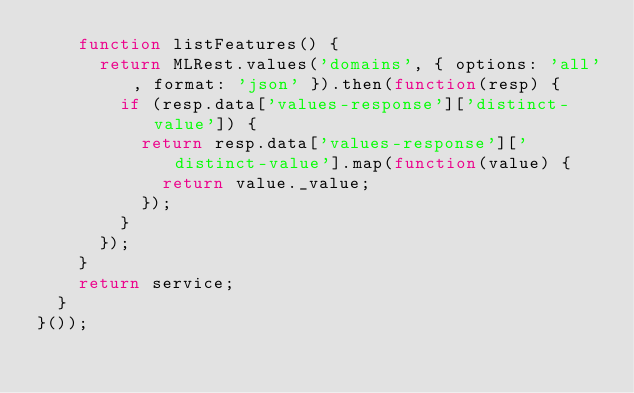Convert code to text. <code><loc_0><loc_0><loc_500><loc_500><_JavaScript_>    function listFeatures() {
      return MLRest.values('domains', { options: 'all', format: 'json' }).then(function(resp) {
        if (resp.data['values-response']['distinct-value']) {
          return resp.data['values-response']['distinct-value'].map(function(value) {
            return value._value;
          });
        }
      });
    }
    return service;
  }
}());
</code> 